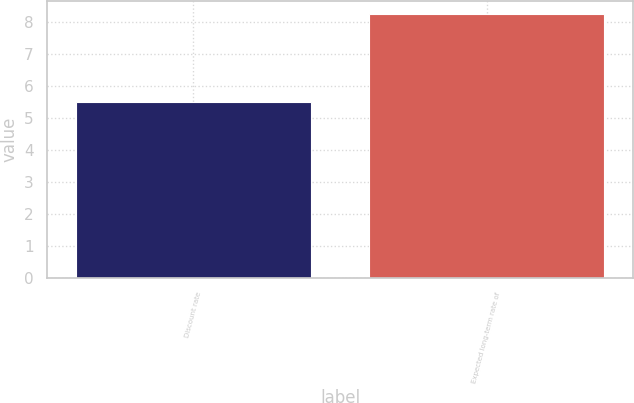Convert chart to OTSL. <chart><loc_0><loc_0><loc_500><loc_500><bar_chart><fcel>Discount rate<fcel>Expected long-term rate of<nl><fcel>5.5<fcel>8.25<nl></chart> 